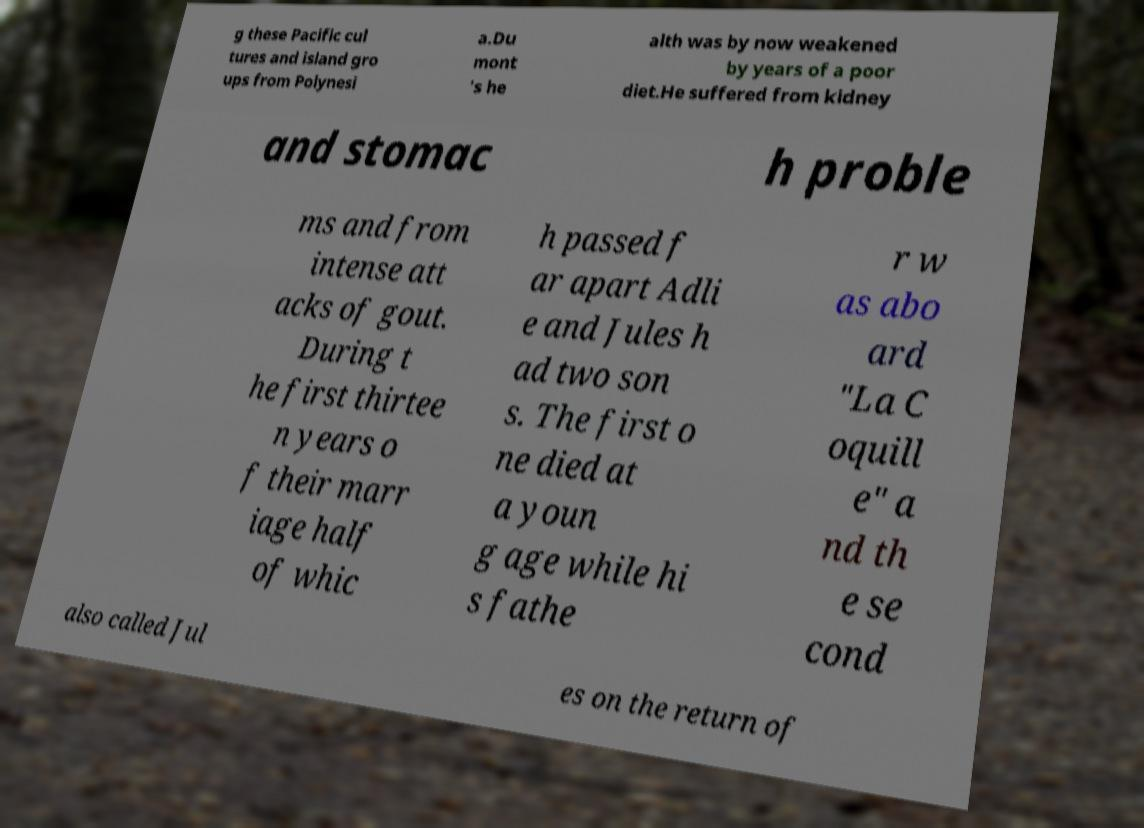Could you extract and type out the text from this image? g these Pacific cul tures and island gro ups from Polynesi a.Du mont 's he alth was by now weakened by years of a poor diet.He suffered from kidney and stomac h proble ms and from intense att acks of gout. During t he first thirtee n years o f their marr iage half of whic h passed f ar apart Adli e and Jules h ad two son s. The first o ne died at a youn g age while hi s fathe r w as abo ard "La C oquill e" a nd th e se cond also called Jul es on the return of 